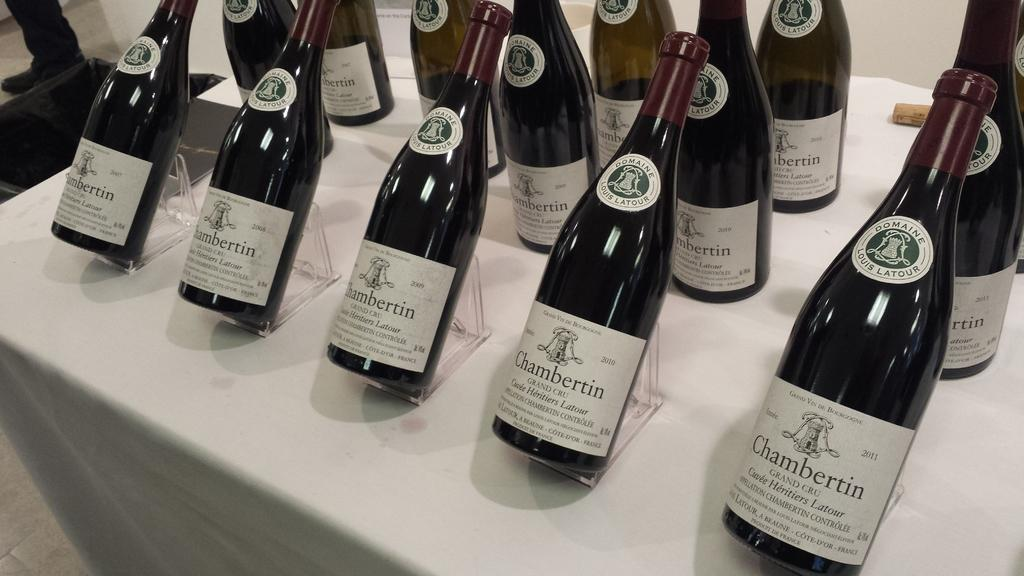What is the main subject of the image? The main subject of the image is many bottles. How are the bottles arranged in the image? The bottles are standing on a stand. What can be read on the bottles in the image? The word "Chambertin" is written on the bottles. How many children are playing in harmony with the owl in the image? There are no children or owls present in the image; it only features bottles standing on a stand with the word "Chambertin" written on them. 